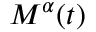<formula> <loc_0><loc_0><loc_500><loc_500>M ^ { \alpha } ( t )</formula> 